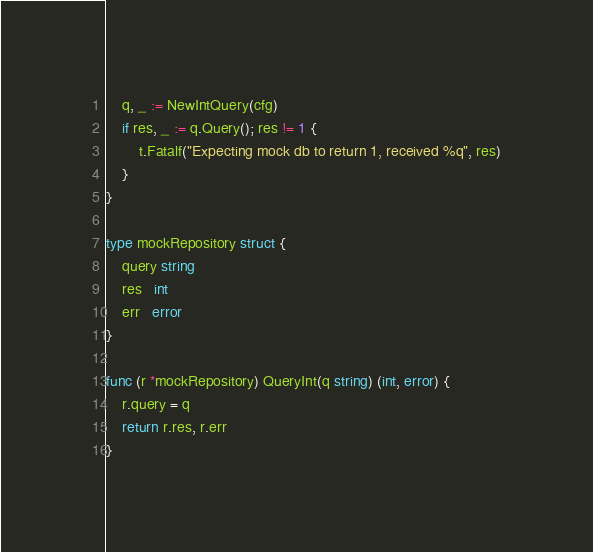<code> <loc_0><loc_0><loc_500><loc_500><_Go_>	q, _ := NewIntQuery(cfg)
	if res, _ := q.Query(); res != 1 {
		t.Fatalf("Expecting mock db to return 1, received %q", res)
	}
}

type mockRepository struct {
	query string
	res   int
	err   error
}

func (r *mockRepository) QueryInt(q string) (int, error) {
	r.query = q
	return r.res, r.err
}
</code> 